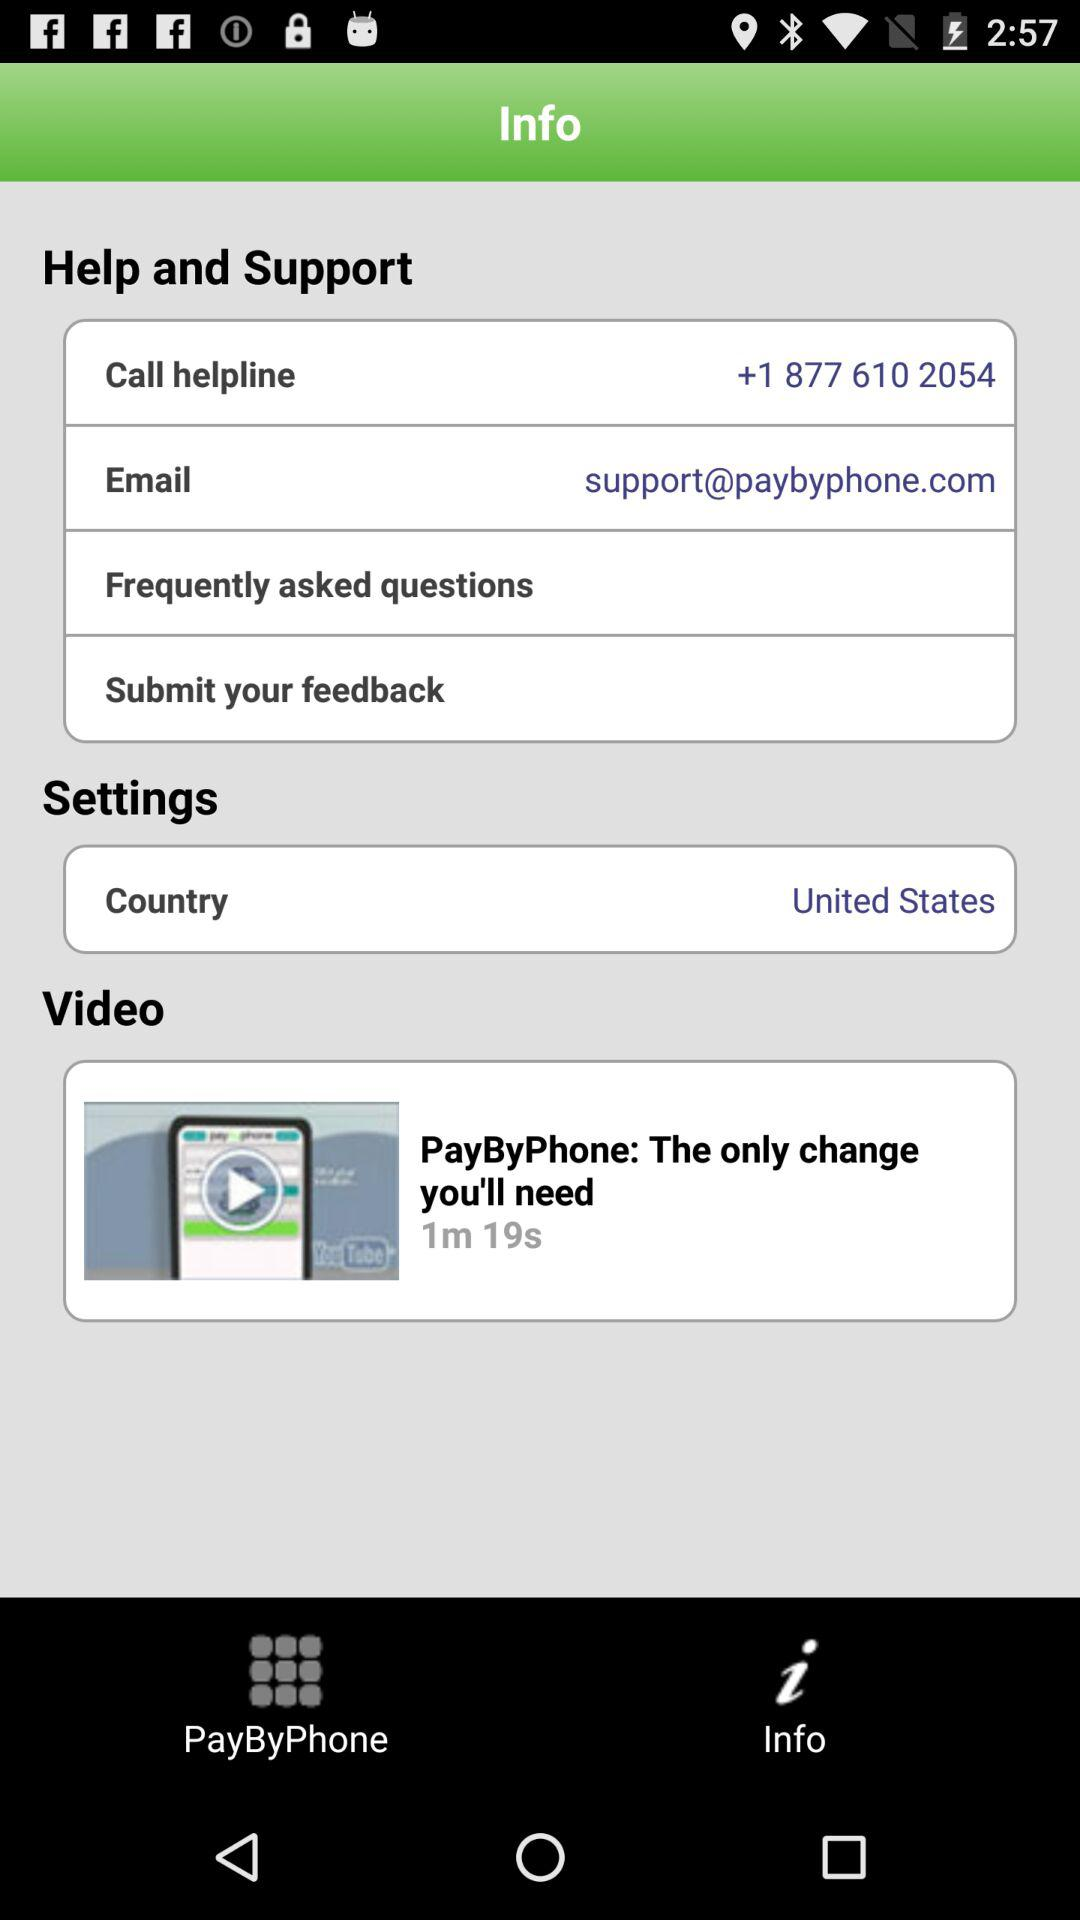What is the given email address? The given email address is support@paybyphone.com. 